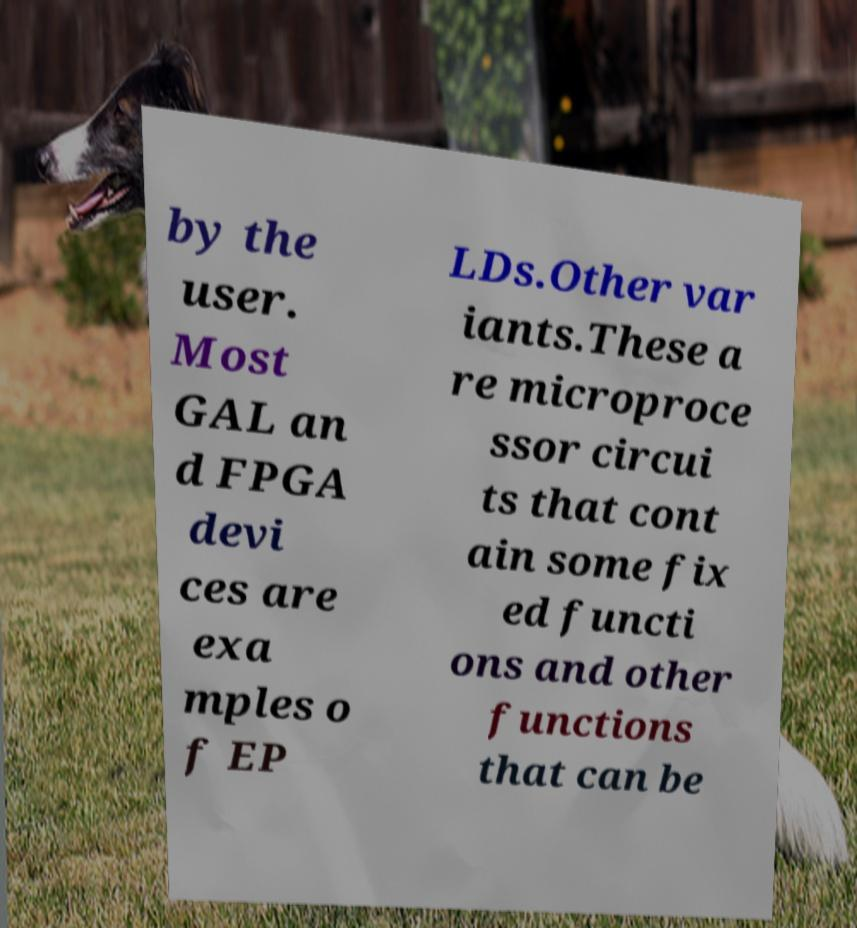Could you assist in decoding the text presented in this image and type it out clearly? by the user. Most GAL an d FPGA devi ces are exa mples o f EP LDs.Other var iants.These a re microproce ssor circui ts that cont ain some fix ed functi ons and other functions that can be 